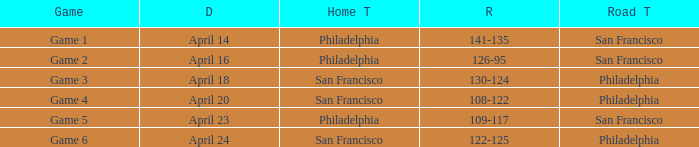Which games had Philadelphia as home team? Game 1, Game 2, Game 5. 